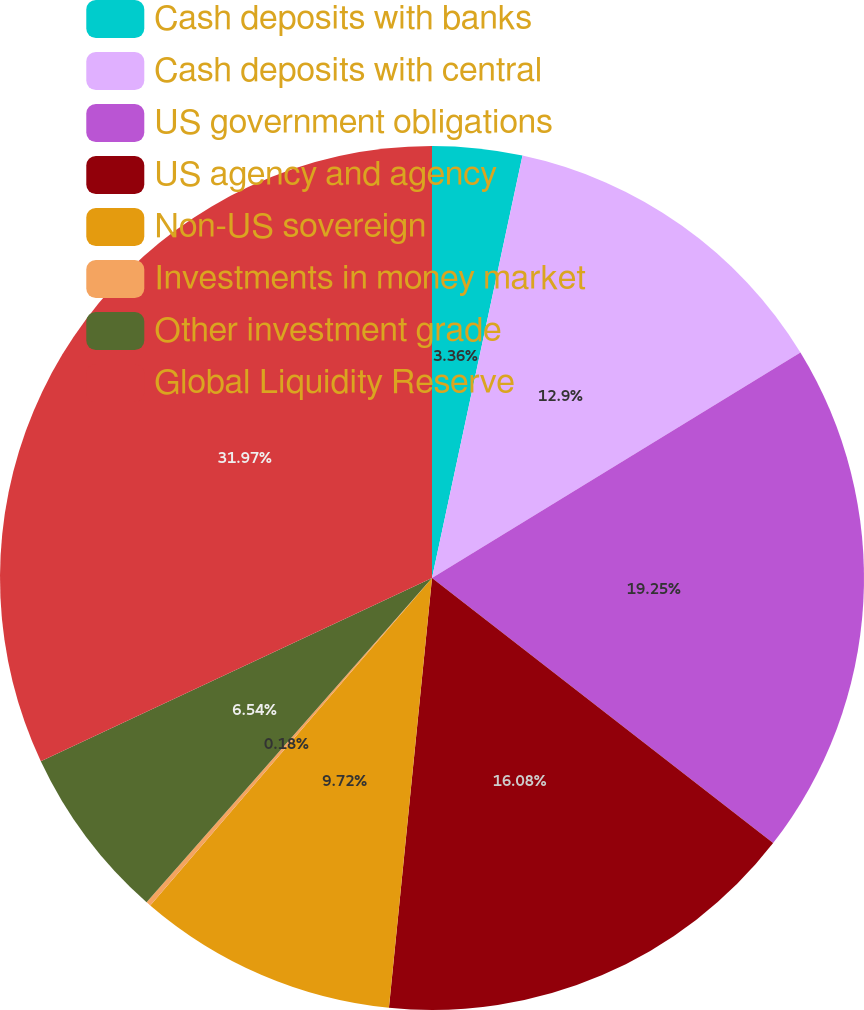<chart> <loc_0><loc_0><loc_500><loc_500><pie_chart><fcel>Cash deposits with banks<fcel>Cash deposits with central<fcel>US government obligations<fcel>US agency and agency<fcel>Non-US sovereign<fcel>Investments in money market<fcel>Other investment grade<fcel>Global Liquidity Reserve<nl><fcel>3.36%<fcel>12.9%<fcel>19.26%<fcel>16.08%<fcel>9.72%<fcel>0.18%<fcel>6.54%<fcel>31.98%<nl></chart> 